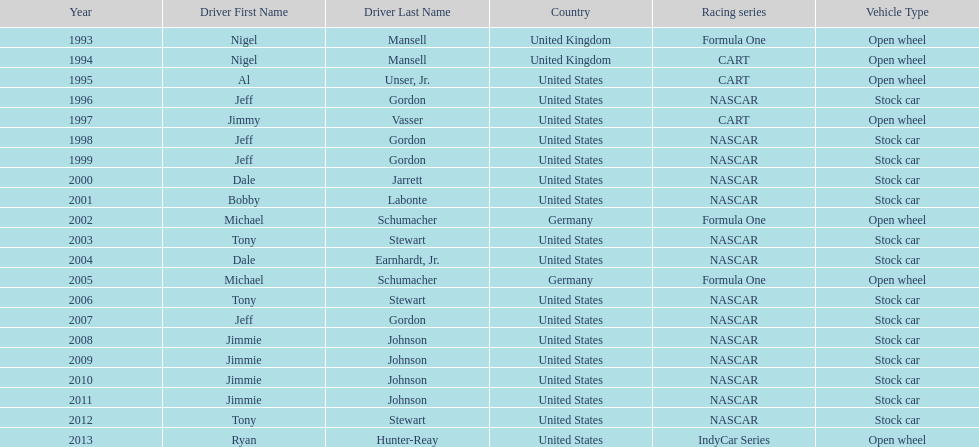Does the united states have more nation of citzenship then united kingdom? Yes. 